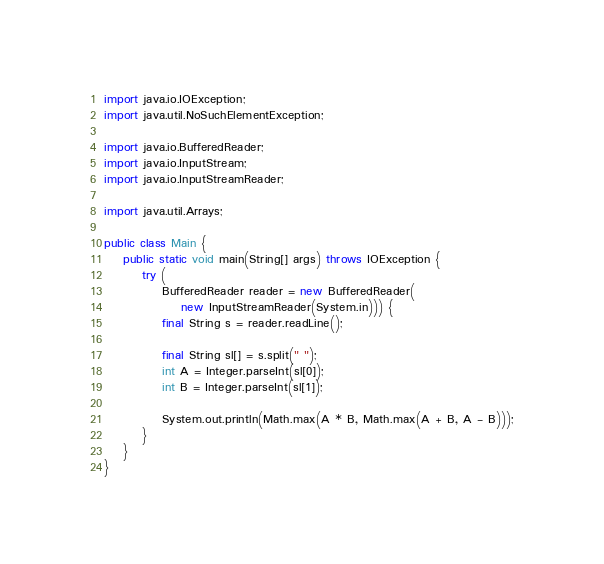<code> <loc_0><loc_0><loc_500><loc_500><_Java_>import java.io.IOException;
import java.util.NoSuchElementException;

import java.io.BufferedReader;
import java.io.InputStream;
import java.io.InputStreamReader;

import java.util.Arrays;

public class Main {
    public static void main(String[] args) throws IOException {
        try (
            BufferedReader reader = new BufferedReader(
                new InputStreamReader(System.in))) {
            final String s = reader.readLine();

            final String sl[] = s.split(" ");
            int A = Integer.parseInt(sl[0]);
            int B = Integer.parseInt(sl[1]);

            System.out.println(Math.max(A * B, Math.max(A + B, A - B)));
        }
    }
}
</code> 